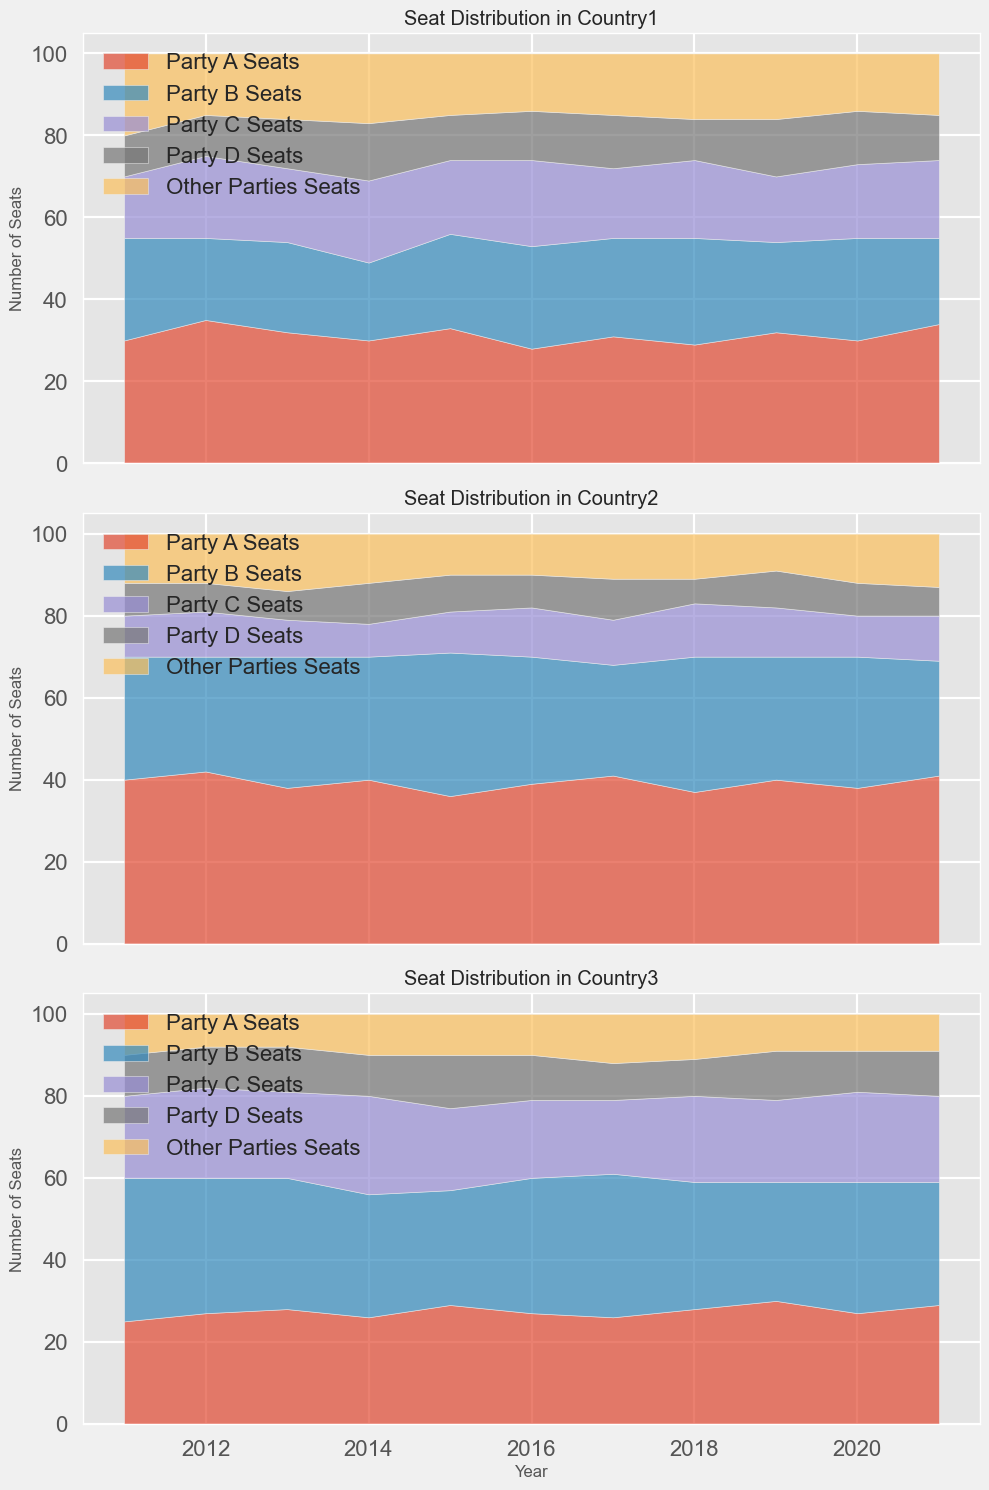What trends can be observed for Party A in Country1 over the decade? By examining the plotted area for Party A in the top plot, we can observe the ups and downs in the number of seats. Looking at years 2011 to 2021, Party A's seats started at 30 in 2011, fluctuated with an increase in 2012 at 35, and ended at 34 in 2021, indicating a slight overall increasing trend.
Answer: Slight increase Which party had the most stable number of seats in Country3 during the period? To identify stability, we need to observe the plot for Country3 and look for the party with the smallest fluctuations in their area. Party D's seats remained mostly unchanged between 9 and 13 seats over the decade, exhibiting the most stability compared to other parties.
Answer: Party D In which year did Party B and Party C in Country2 together have the highest number of seats? Let's find the section of the middle plot for Country2. We need to sum the seats of Party B and Party C for each year and compare them. The highest sum occurs in 2015 with Party B holding 35 seats and Party C holding 10, totaling 45 seats.
Answer: 2015 Were there any instances where "Other Parties" in Country1 were the majority seat holders in any year? To answer this, we need to check the area plot for Country1 and compare the 'Other Parties' area with other parties for each year. No, the 'Other Parties' were never the largest seat holders in any single year.
Answer: No How did Party A's seats in Country2 change relative to Party B's from 2017 to 2018? To determine this, compare the height change of Party A and Party B areas between 2017 and 2018 in Country2. Party A's seats decreased from 41 to 37, while Party B's increased from 27 to 33. Party A decreased by 4 and Party B increased by 6.
Answer: Party A decreased, Party B increased Which party had the least number of seats in Country3 in 2014? In the plot for Country3, observe the year 2014. The area representing Party D is the smallest in this year with only 10 seats.
Answer: Party D In Country1, during which years did Party C have more seats than Party B? Reviewing the plot for Country1, compare the areas for Party B and Party C year by year. Party C had more seats than Party B in the years 2012 and 2016.
Answer: 2012 and 2016 During which years did "Other Parties" in Country2 hold an equal share of seats? Looking at the "Other Parties" areas in the plot for Country2, we need to identify years where the height remains the same. The number of seats is constant in 2011, 2012, and 2014, each with 12 seats.
Answer: 2011, 2012, and 2014 